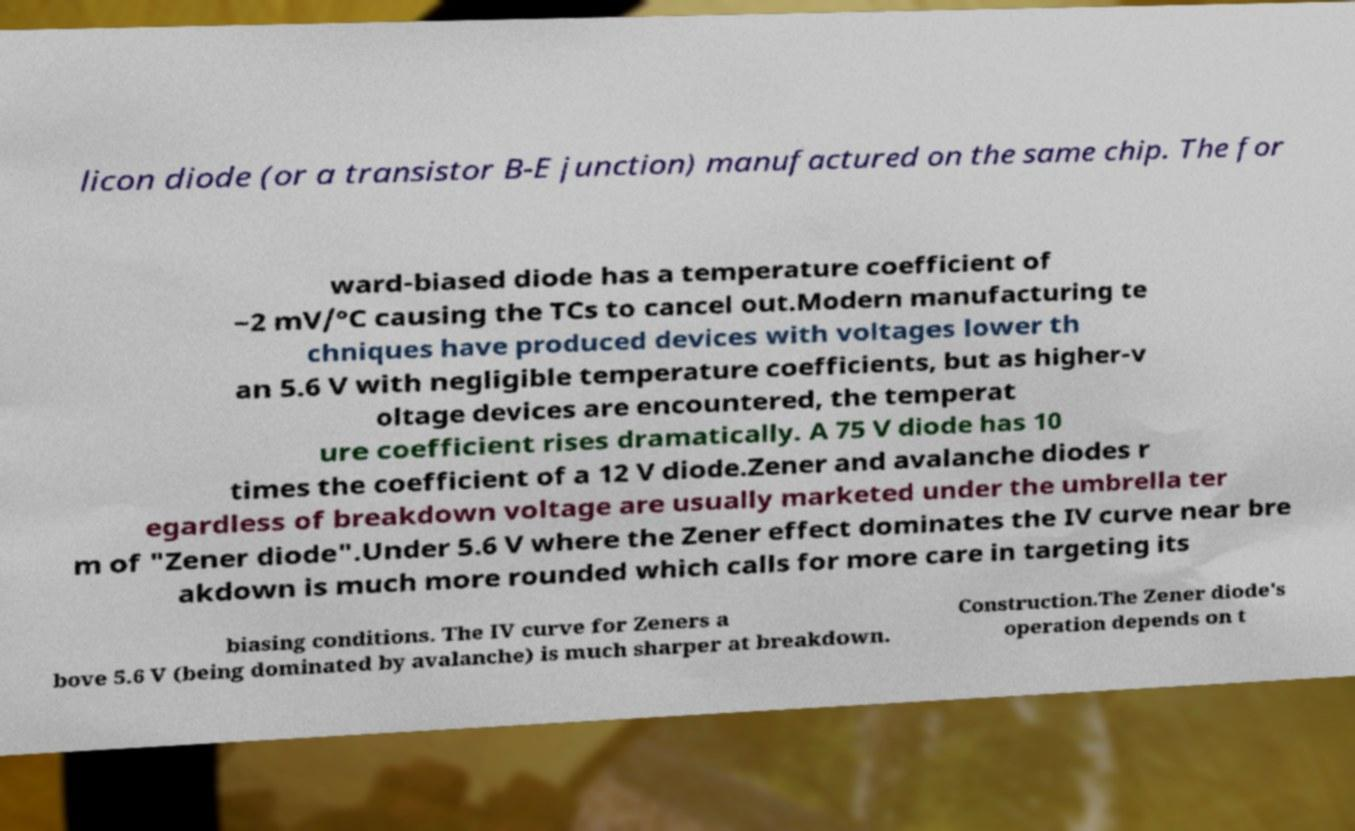I need the written content from this picture converted into text. Can you do that? licon diode (or a transistor B-E junction) manufactured on the same chip. The for ward-biased diode has a temperature coefficient of −2 mV/°C causing the TCs to cancel out.Modern manufacturing te chniques have produced devices with voltages lower th an 5.6 V with negligible temperature coefficients, but as higher-v oltage devices are encountered, the temperat ure coefficient rises dramatically. A 75 V diode has 10 times the coefficient of a 12 V diode.Zener and avalanche diodes r egardless of breakdown voltage are usually marketed under the umbrella ter m of "Zener diode".Under 5.6 V where the Zener effect dominates the IV curve near bre akdown is much more rounded which calls for more care in targeting its biasing conditions. The IV curve for Zeners a bove 5.6 V (being dominated by avalanche) is much sharper at breakdown. Construction.The Zener diode's operation depends on t 